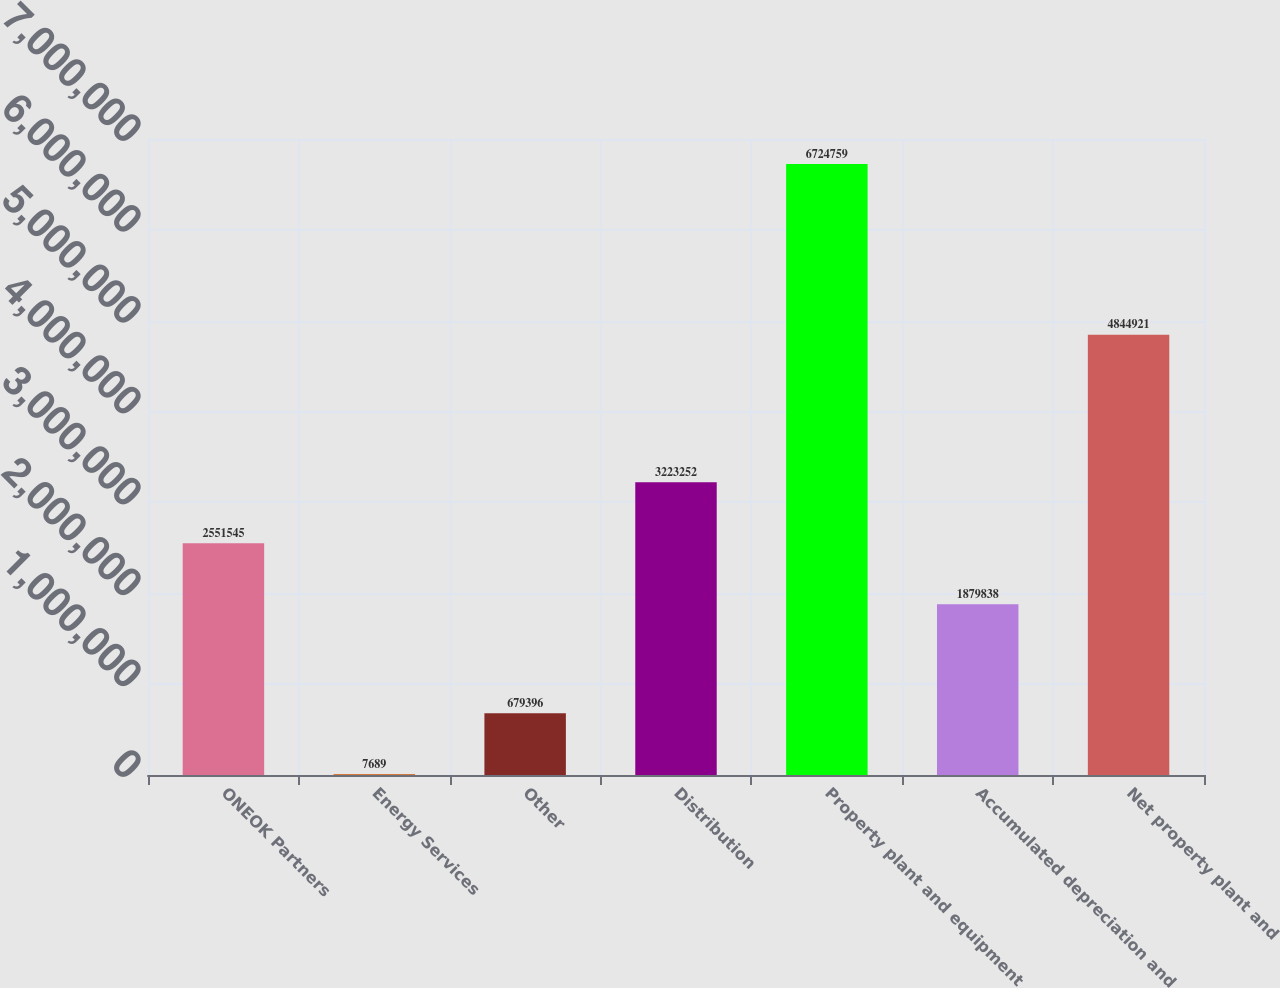<chart> <loc_0><loc_0><loc_500><loc_500><bar_chart><fcel>ONEOK Partners<fcel>Energy Services<fcel>Other<fcel>Distribution<fcel>Property plant and equipment<fcel>Accumulated depreciation and<fcel>Net property plant and<nl><fcel>2.55154e+06<fcel>7689<fcel>679396<fcel>3.22325e+06<fcel>6.72476e+06<fcel>1.87984e+06<fcel>4.84492e+06<nl></chart> 